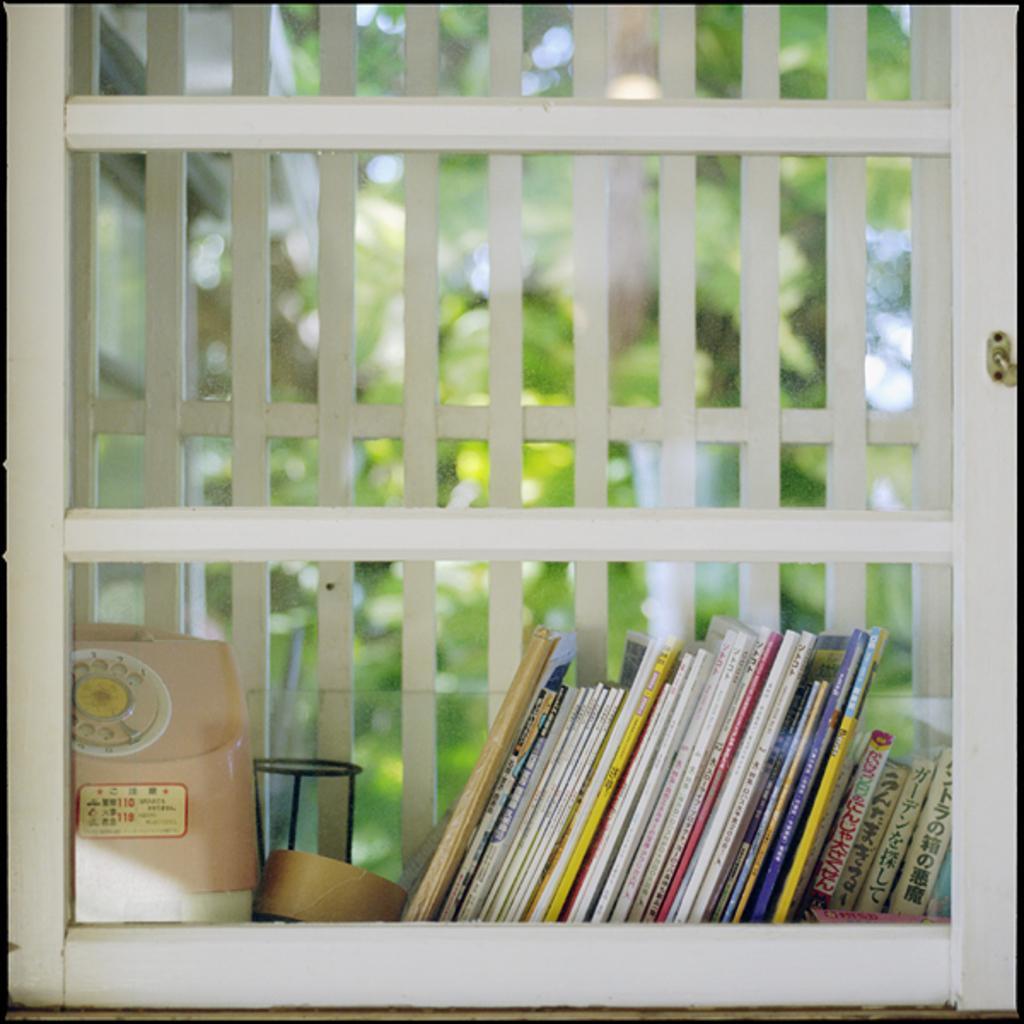Please provide a concise description of this image. In this image we can see books and some objects placed in the rack. In the background we can see trees through the glass. 